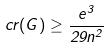<formula> <loc_0><loc_0><loc_500><loc_500>c r ( G ) \geq \frac { e ^ { 3 } } { 2 9 n ^ { 2 } }</formula> 